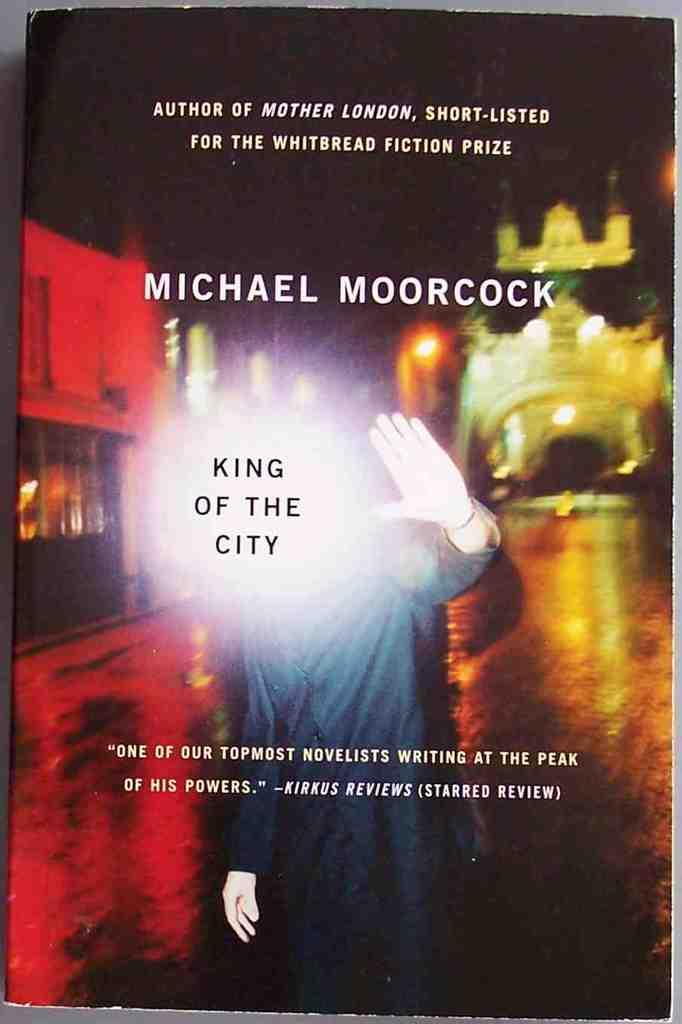Provide a one-sentence caption for the provided image. The King of the City standing in front of a bridge with his hand held up. 